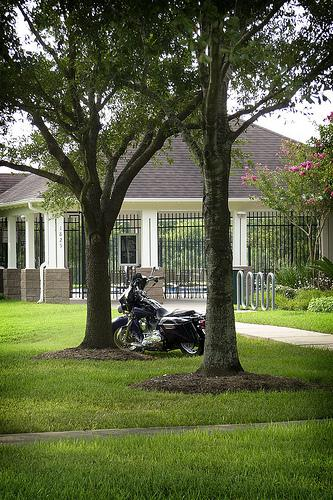Question: where is the picture taken?
Choices:
A. Near a building.
B. Inside.
C. At table.
D. At work.
Answer with the letter. Answer: A Question: what is the color of the roof?
Choices:
A. Grey.
B. Light black.
C. Dark silver.
D. Smokey.
Answer with the letter. Answer: A Question: what is the color of the grass?
Choices:
A. Aqua.
B. Teal.
C. Brown.
D. Green.
Answer with the letter. Answer: D Question: what is standing near the tree?
Choices:
A. Motorcycle.
B. Scooter.
C. Bike.
D. Tricycle.
Answer with the letter. Answer: C Question: what is the color of the bike?
Choices:
A. Ebony.
B. Red.
C. Black.
D. Blue.
Answer with the letter. Answer: C 